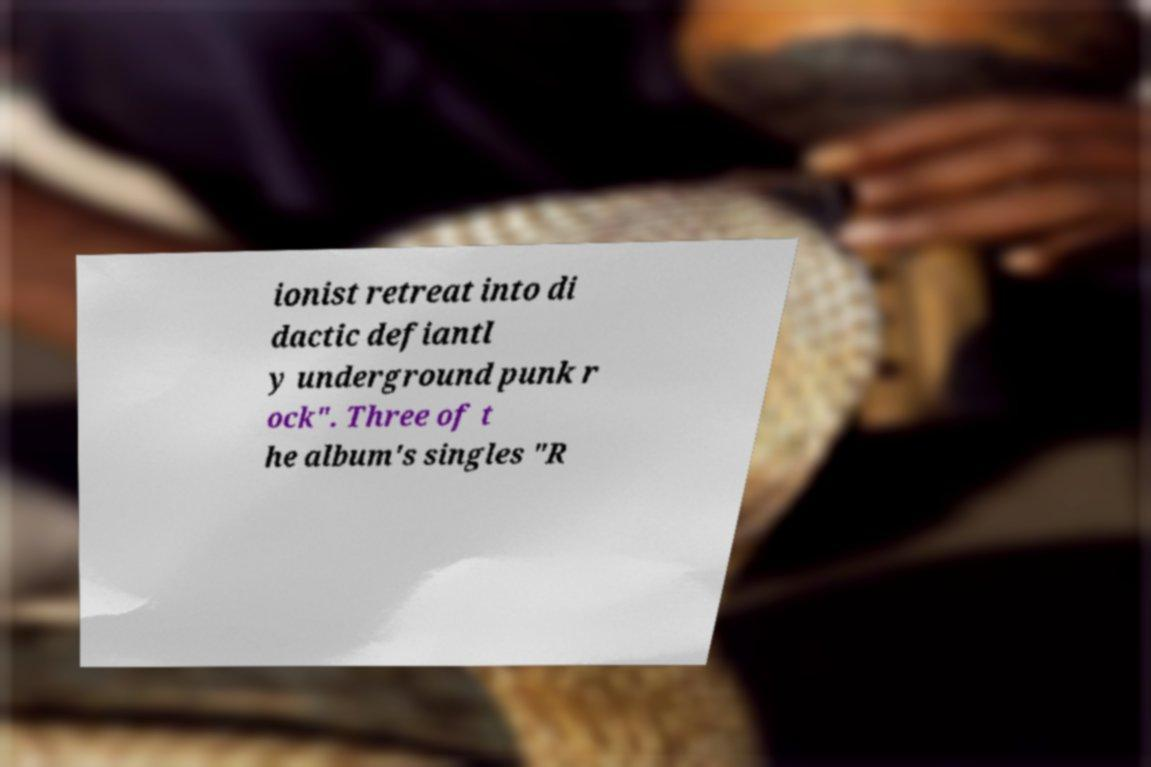I need the written content from this picture converted into text. Can you do that? ionist retreat into di dactic defiantl y underground punk r ock". Three of t he album's singles "R 